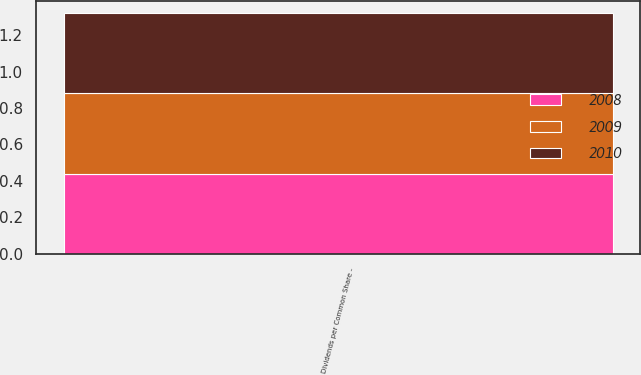Convert chart. <chart><loc_0><loc_0><loc_500><loc_500><stacked_bar_chart><ecel><fcel>Dividends per Common Share -<nl><fcel>2010<fcel>0.44<nl><fcel>2008<fcel>0.44<nl><fcel>2009<fcel>0.44<nl></chart> 